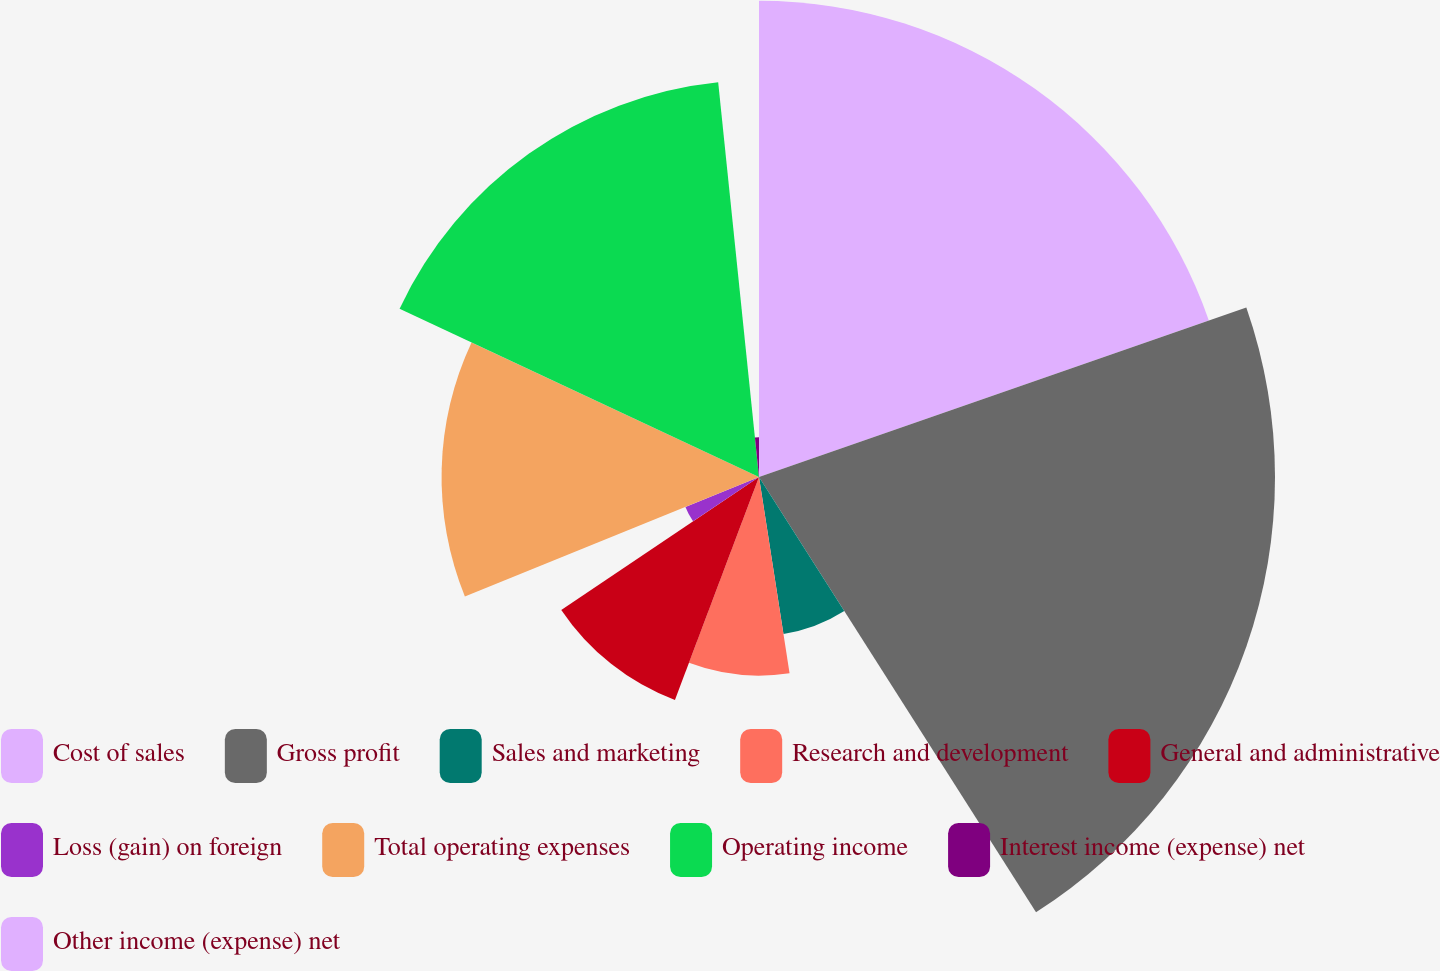Convert chart to OTSL. <chart><loc_0><loc_0><loc_500><loc_500><pie_chart><fcel>Cost of sales<fcel>Gross profit<fcel>Sales and marketing<fcel>Research and development<fcel>General and administrative<fcel>Loss (gain) on foreign<fcel>Total operating expenses<fcel>Operating income<fcel>Interest income (expense) net<fcel>Other income (expense) net<nl><fcel>19.67%<fcel>21.31%<fcel>6.56%<fcel>8.2%<fcel>9.84%<fcel>3.28%<fcel>13.11%<fcel>16.39%<fcel>1.64%<fcel>0.0%<nl></chart> 